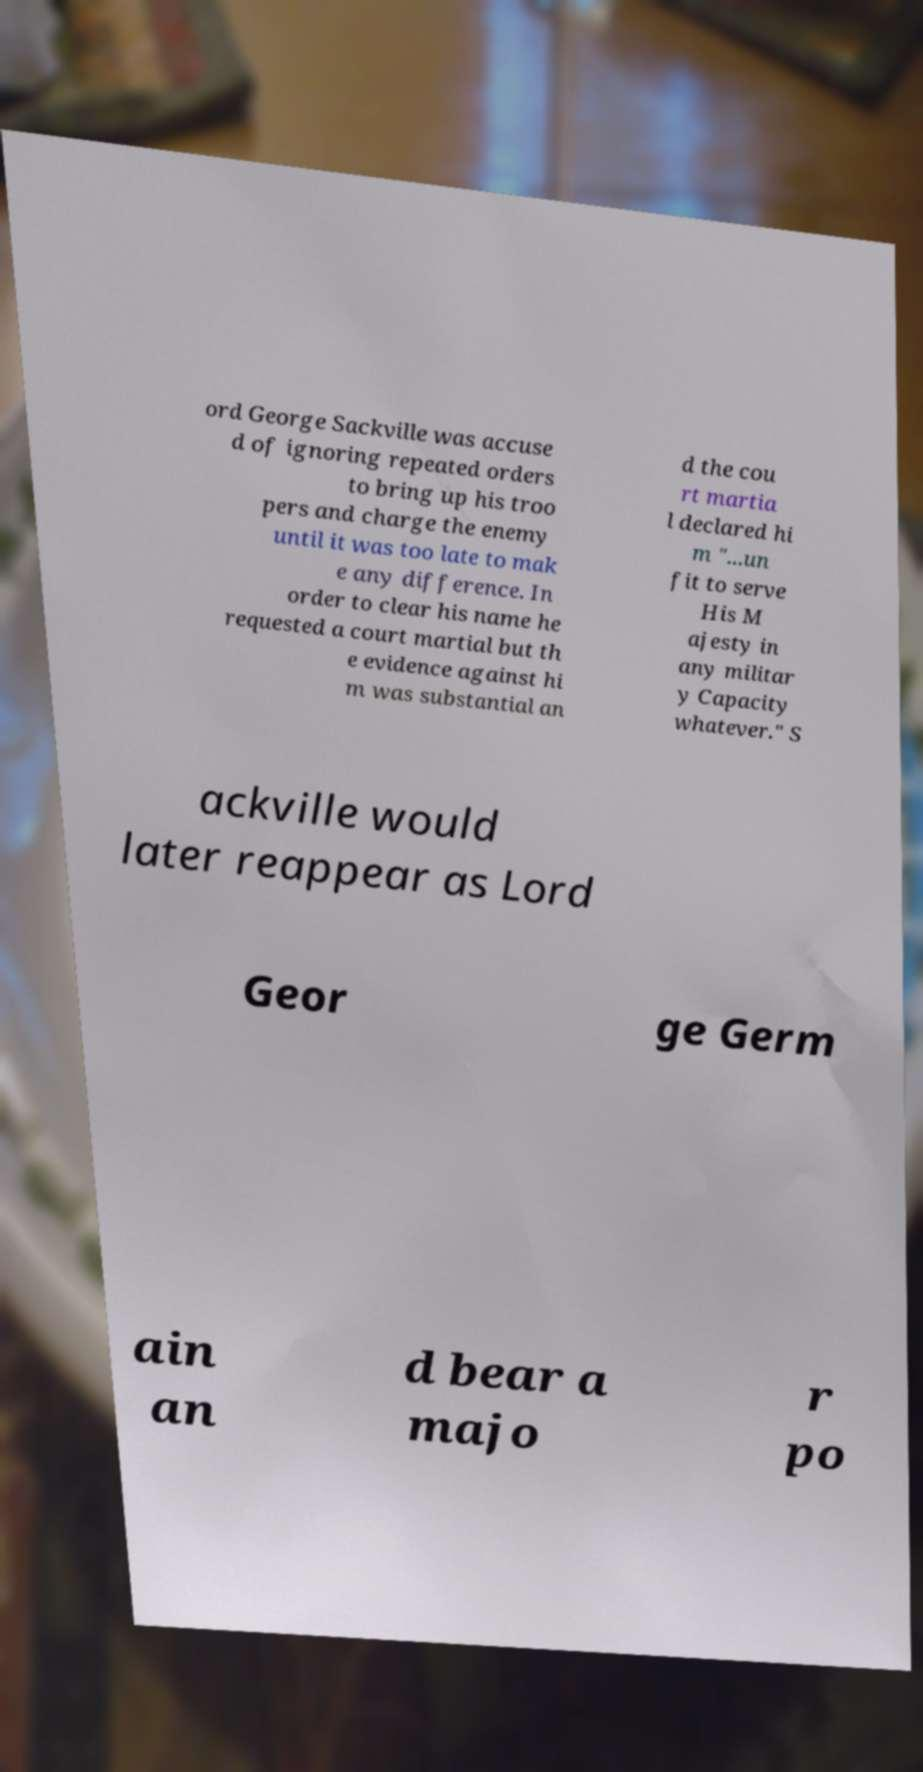There's text embedded in this image that I need extracted. Can you transcribe it verbatim? ord George Sackville was accuse d of ignoring repeated orders to bring up his troo pers and charge the enemy until it was too late to mak e any difference. In order to clear his name he requested a court martial but th e evidence against hi m was substantial an d the cou rt martia l declared hi m "...un fit to serve His M ajesty in any militar y Capacity whatever." S ackville would later reappear as Lord Geor ge Germ ain an d bear a majo r po 